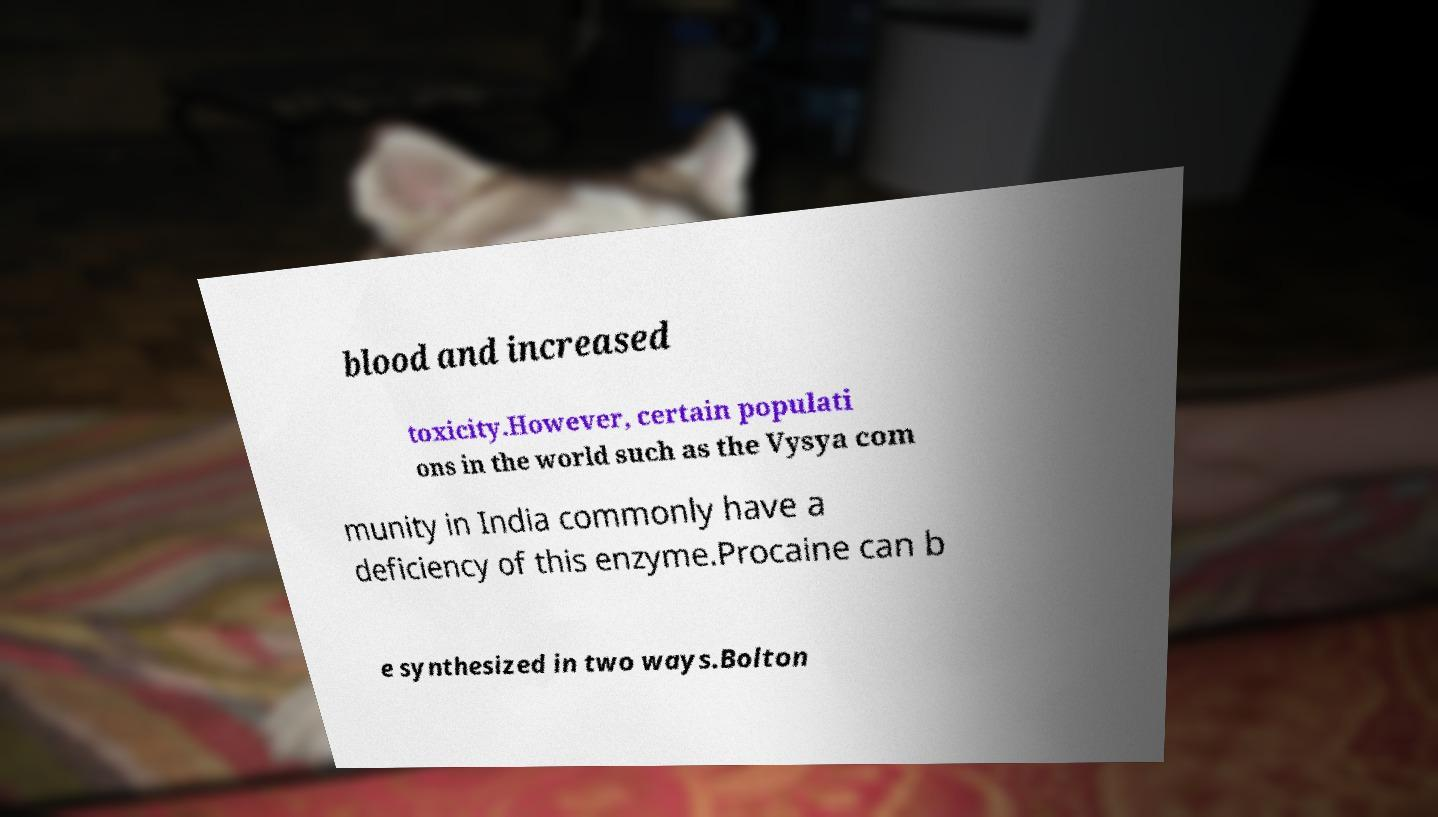I need the written content from this picture converted into text. Can you do that? blood and increased toxicity.However, certain populati ons in the world such as the Vysya com munity in India commonly have a deficiency of this enzyme.Procaine can b e synthesized in two ways.Bolton 